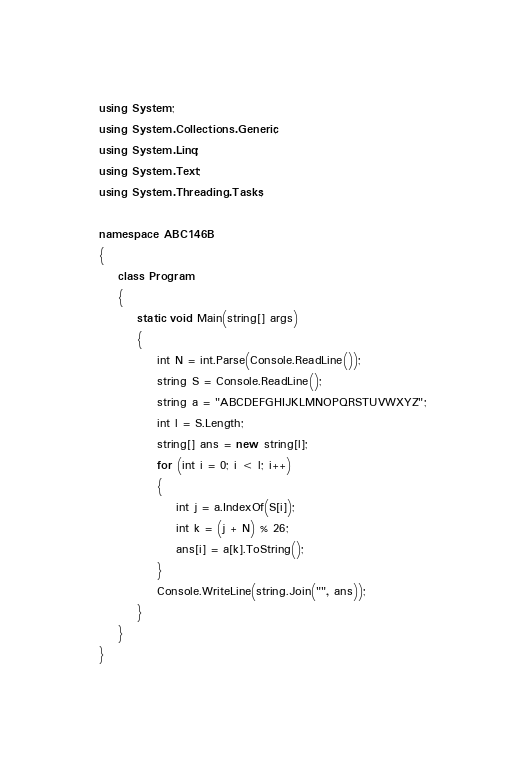<code> <loc_0><loc_0><loc_500><loc_500><_C#_>using System;
using System.Collections.Generic;
using System.Linq;
using System.Text;
using System.Threading.Tasks;

namespace ABC146B
{
    class Program
    {
        static void Main(string[] args)
        {
            int N = int.Parse(Console.ReadLine());
            string S = Console.ReadLine();
            string a = "ABCDEFGHIJKLMNOPQRSTUVWXYZ";
            int l = S.Length;
            string[] ans = new string[l];
            for (int i = 0; i < l; i++)
            {
                int j = a.IndexOf(S[i]);
                int k = (j + N) % 26;
                ans[i] = a[k].ToString();
            }
            Console.WriteLine(string.Join("", ans));
        }
    }
}
</code> 